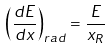Convert formula to latex. <formula><loc_0><loc_0><loc_500><loc_500>\left ( \frac { d E } { d x } \right ) _ { r a d } = \frac { E } { x _ { R } }</formula> 